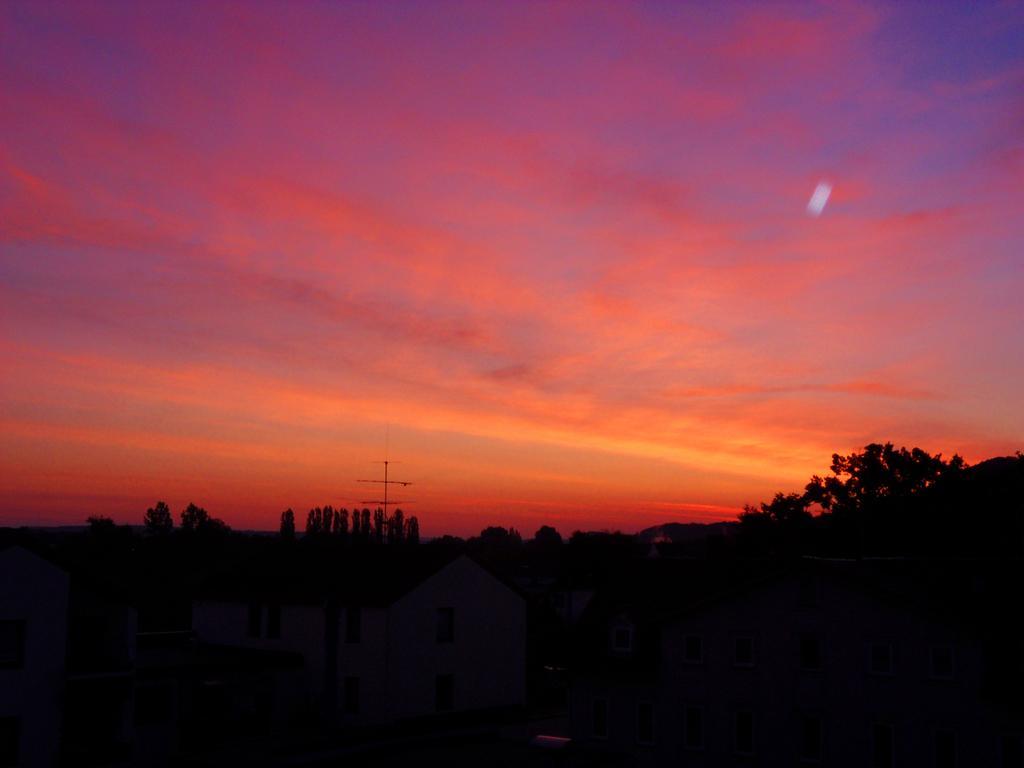In one or two sentences, can you explain what this image depicts? It is a picture of a sunset the sky is and pink and orange color,there are some houses and they are surrounded with lot of trees. 